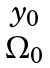Convert formula to latex. <formula><loc_0><loc_0><loc_500><loc_500>\begin{matrix} y _ { 0 } \\ \Omega _ { 0 } \end{matrix}</formula> 